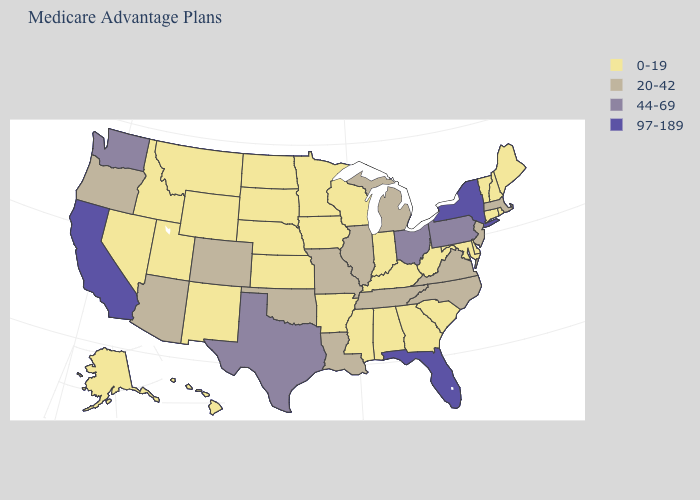Name the states that have a value in the range 0-19?
Keep it brief. Alaska, Alabama, Arkansas, Connecticut, Delaware, Georgia, Hawaii, Iowa, Idaho, Indiana, Kansas, Kentucky, Maryland, Maine, Minnesota, Mississippi, Montana, North Dakota, Nebraska, New Hampshire, New Mexico, Nevada, Rhode Island, South Carolina, South Dakota, Utah, Vermont, Wisconsin, West Virginia, Wyoming. Among the states that border South Carolina , which have the highest value?
Be succinct. North Carolina. What is the value of Arizona?
Quick response, please. 20-42. Does California have the highest value in the USA?
Answer briefly. Yes. Is the legend a continuous bar?
Concise answer only. No. Name the states that have a value in the range 97-189?
Quick response, please. California, Florida, New York. Does Alaska have the highest value in the West?
Give a very brief answer. No. Does New Mexico have the highest value in the West?
Be succinct. No. What is the lowest value in states that border Indiana?
Answer briefly. 0-19. Does California have the highest value in the USA?
Keep it brief. Yes. Which states have the lowest value in the Northeast?
Keep it brief. Connecticut, Maine, New Hampshire, Rhode Island, Vermont. Does Illinois have the highest value in the MidWest?
Concise answer only. No. Does Maine have the lowest value in the Northeast?
Keep it brief. Yes. Does Oklahoma have the same value as Arizona?
Be succinct. Yes. What is the lowest value in the West?
Short answer required. 0-19. 